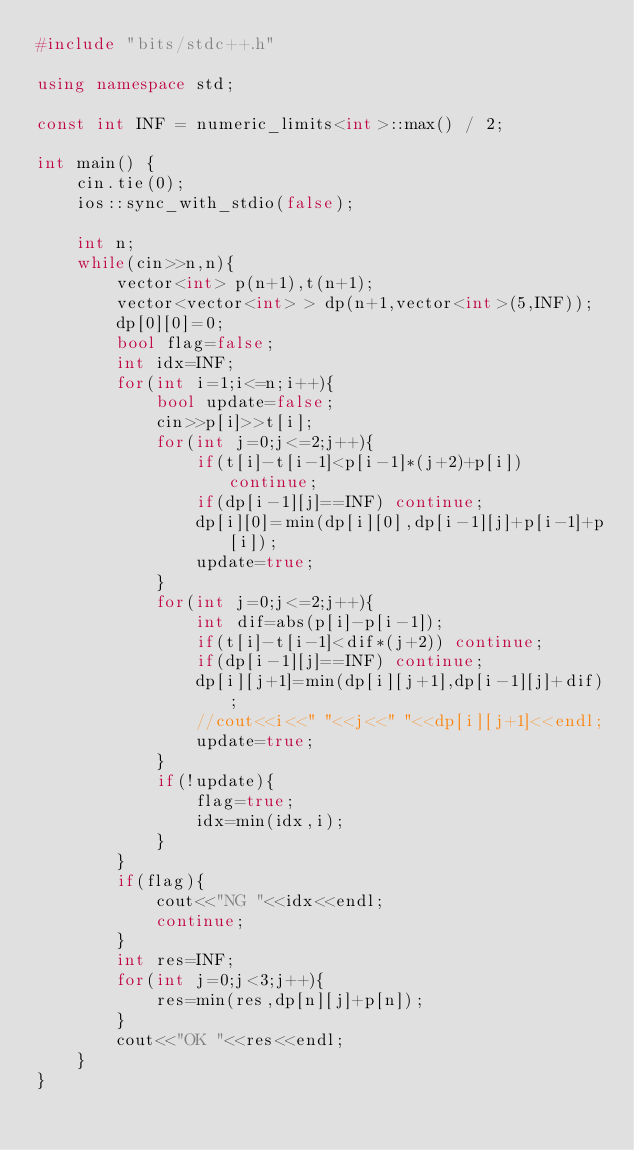<code> <loc_0><loc_0><loc_500><loc_500><_C++_>#include "bits/stdc++.h"

using namespace std;

const int INF = numeric_limits<int>::max() / 2;

int main() {
	cin.tie(0);
	ios::sync_with_stdio(false);

    int n;
    while(cin>>n,n){
        vector<int> p(n+1),t(n+1);
        vector<vector<int> > dp(n+1,vector<int>(5,INF));
        dp[0][0]=0;
        bool flag=false;
        int idx=INF;
        for(int i=1;i<=n;i++){
            bool update=false;
            cin>>p[i]>>t[i];
            for(int j=0;j<=2;j++){
                if(t[i]-t[i-1]<p[i-1]*(j+2)+p[i]) continue;
                if(dp[i-1][j]==INF) continue;
                dp[i][0]=min(dp[i][0],dp[i-1][j]+p[i-1]+p[i]);
                update=true;
            }
            for(int j=0;j<=2;j++){
                int dif=abs(p[i]-p[i-1]);
                if(t[i]-t[i-1]<dif*(j+2)) continue;
                if(dp[i-1][j]==INF) continue;
                dp[i][j+1]=min(dp[i][j+1],dp[i-1][j]+dif);
                //cout<<i<<" "<<j<<" "<<dp[i][j+1]<<endl;
                update=true;
            }
            if(!update){
                flag=true;
                idx=min(idx,i);
            }
        }
        if(flag){
            cout<<"NG "<<idx<<endl;
            continue;
        }
        int res=INF;
        for(int j=0;j<3;j++){
            res=min(res,dp[n][j]+p[n]);
        }
        cout<<"OK "<<res<<endl;
    }
}

</code> 